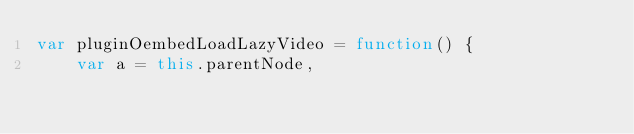Convert code to text. <code><loc_0><loc_0><loc_500><loc_500><_JavaScript_>var pluginOembedLoadLazyVideo = function() {
	var a = this.parentNode,</code> 